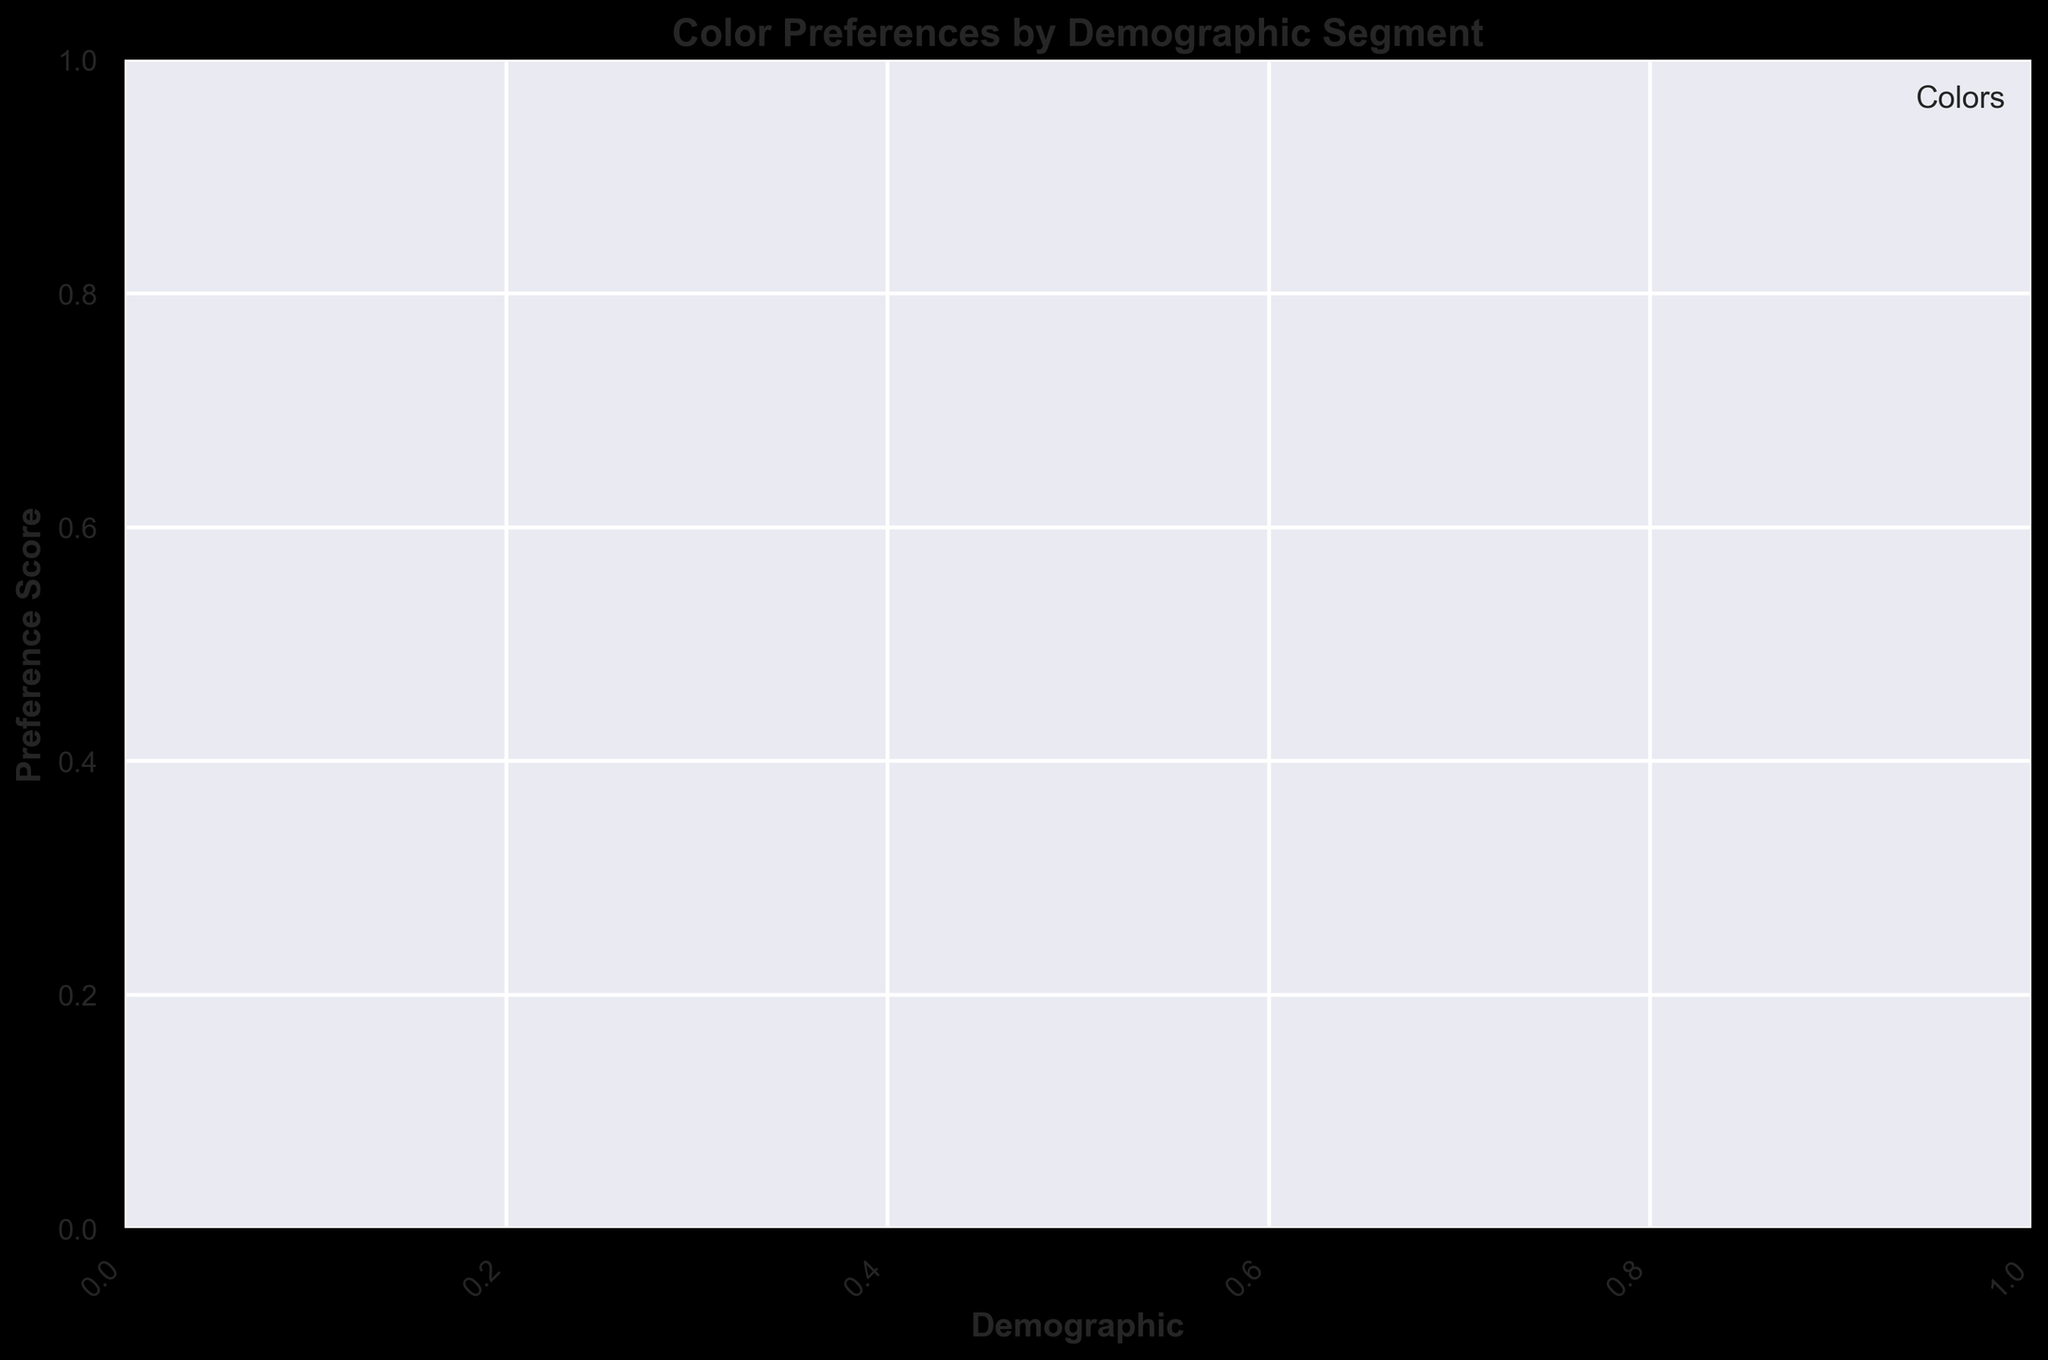What is the color with the highest preference score for the youngest demographic? To determine this, find the scatter points associated with the youngest demographic and identify the color and its corresponding preference score. The highest-yielding color among these points represents the answer.
Answer: [Color] Which color has the most scattered data points across different demographic segments? Count the number of data points for each color across all demographic segments. The color with the highest count indicates the most scattered points.
Answer: [Color] What is the average preference score for the middle-aged demographic, considering all colors? Identify all the points associated with the middle-aged demographic, sum their preference scores, and then divide by the number of points to get the average.
Answer: [Average Score] How does the preference score of blue compare between young and old demographics? Look for blue data points across the young and old demographics, and compare their preference scores visually or through averaging if multiple points exist.
Answer: [Comparison] Which demographic segment shows the highest preference for red and what is the score? Find all red data points and identify the one with the highest preference score; note the associated demographic.
Answer: [Demographic, Score] Are there any demographics that show an equal preference for two different colors? Examine each demographic segment to see if two colors have the same preference score.
Answer: [Yes/No, Demographics if applicable] What is the overall trend in color preference as the demographic age increases? Observe the pattern of preference scores for each color across increasing demographic groups to identify any trends or changes.
Answer: [Trend Observation] Which color shows the least variance in preference scores across all demographics? Calculate the variance of preference scores for each color by finding the difference of each score from the color's mean score, and identify the color with the smallest variance.
Answer: [Color] How many colors have a preference score above 80 for at least one demographic? Count the number of colors with at least one data point having a preference score above 80.
Answer: [Number of Colors] What can be inferred about the preference of green across different demographics? Analyze the location and distribution of the green points across various demographic segments to draw insights about its general acceptance and variability.
Answer: [Inference on Green] 